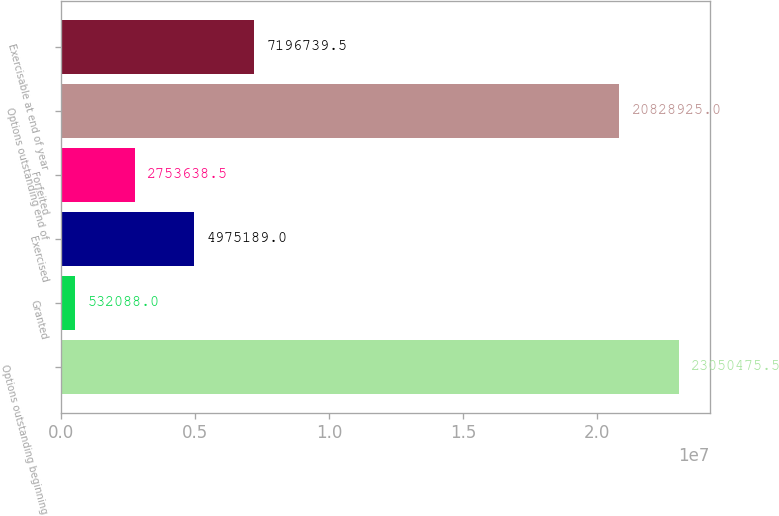<chart> <loc_0><loc_0><loc_500><loc_500><bar_chart><fcel>Options outstanding beginning<fcel>Granted<fcel>Exercised<fcel>Forfeited<fcel>Options outstanding end of<fcel>Exercisable at end of year<nl><fcel>2.30505e+07<fcel>532088<fcel>4.97519e+06<fcel>2.75364e+06<fcel>2.08289e+07<fcel>7.19674e+06<nl></chart> 